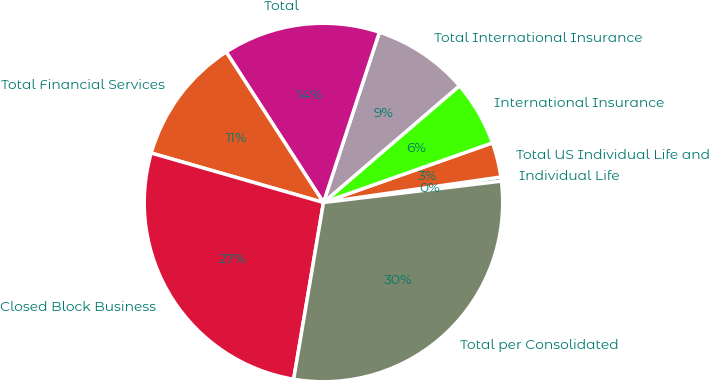<chart> <loc_0><loc_0><loc_500><loc_500><pie_chart><fcel>Individual Life<fcel>Total US Individual Life and<fcel>International Insurance<fcel>Total International Insurance<fcel>Total<fcel>Total Financial Services<fcel>Closed Block Business<fcel>Total per Consolidated<nl><fcel>0.37%<fcel>3.13%<fcel>5.89%<fcel>8.66%<fcel>14.18%<fcel>11.42%<fcel>26.79%<fcel>29.56%<nl></chart> 